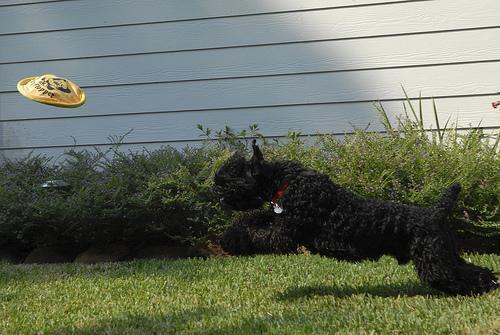How many frisbees are there?
Give a very brief answer. 1. 